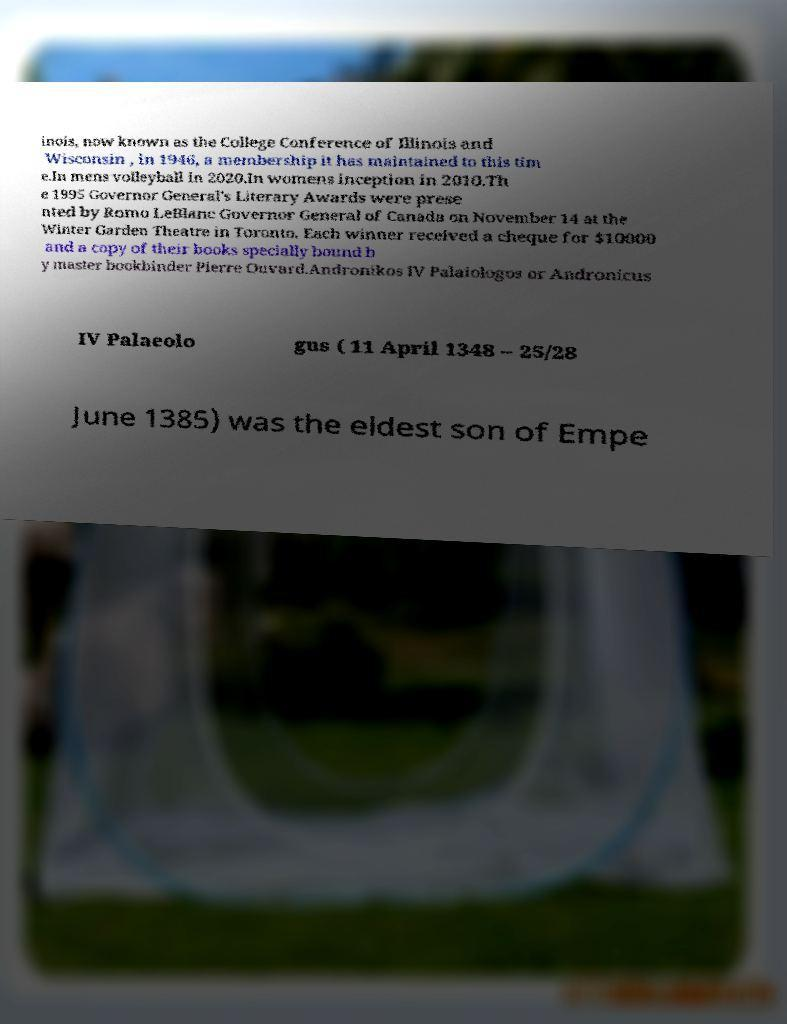What messages or text are displayed in this image? I need them in a readable, typed format. inois, now known as the College Conference of Illinois and Wisconsin , in 1946, a membership it has maintained to this tim e.In mens volleyball in 2020.In womens inception in 2010.Th e 1995 Governor General's Literary Awards were prese nted by Romo LeBlanc Governor General of Canada on November 14 at the Winter Garden Theatre in Toronto. Each winner received a cheque for $10000 and a copy of their books specially bound b y master bookbinder Pierre Ouvard.Andronikos IV Palaiologos or Andronicus IV Palaeolo gus ( 11 April 1348 – 25/28 June 1385) was the eldest son of Empe 